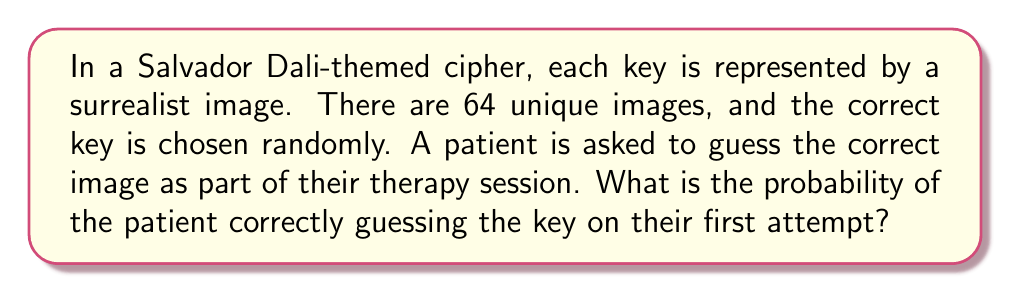What is the answer to this math problem? To solve this problem, we need to understand the concept of probability in the context of a random selection from a finite set of options. Here's a step-by-step explanation:

1. Identify the total number of possible outcomes:
   In this case, there are 64 unique surrealist images.

2. Identify the number of favorable outcomes:
   We are interested in selecting the correct key, which is only one image.

3. Calculate the probability using the formula:
   $$P(\text{correct guess}) = \frac{\text{number of favorable outcomes}}{\text{total number of possible outcomes}}$$

4. Substitute the values:
   $$P(\text{correct guess}) = \frac{1}{64}$$

5. Simplify the fraction:
   The fraction $\frac{1}{64}$ is already in its simplest form.

Therefore, the probability of correctly guessing the key on the first attempt is $\frac{1}{64}$.
Answer: $\frac{1}{64}$ 